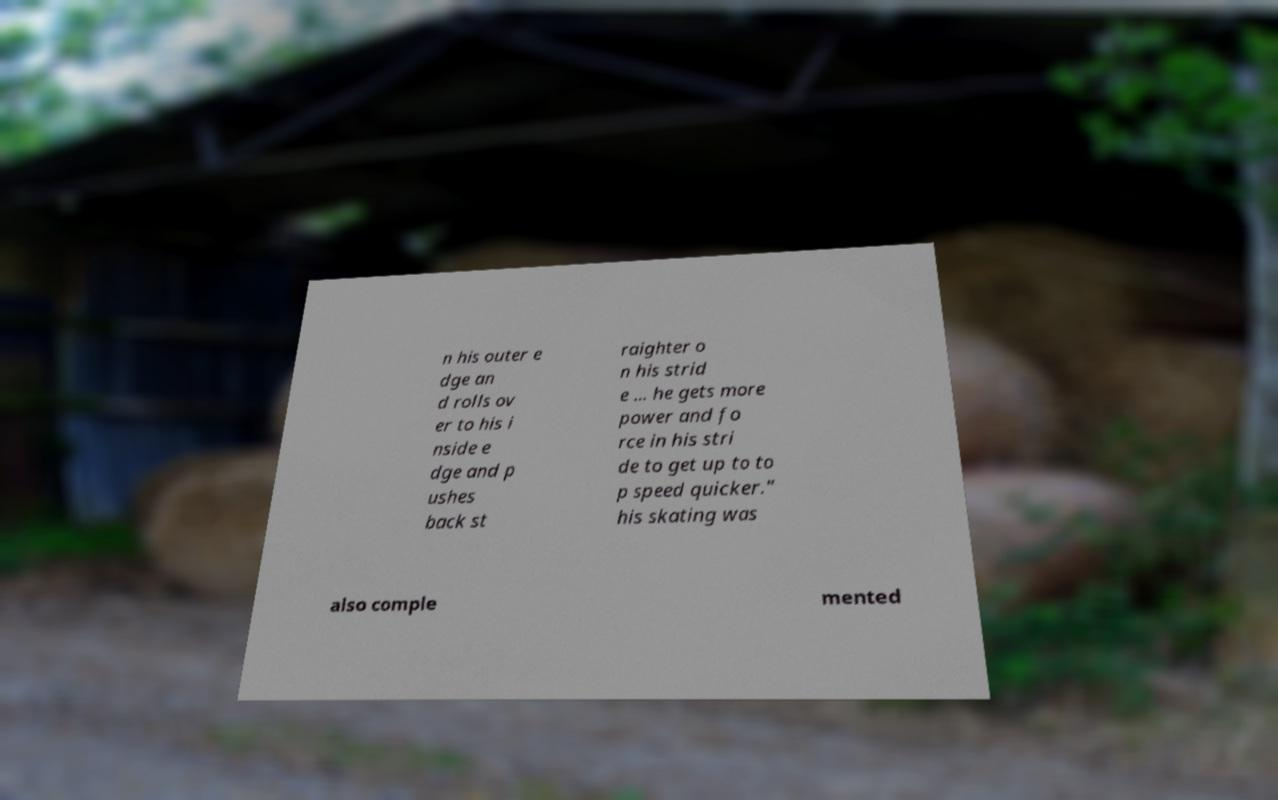Please read and relay the text visible in this image. What does it say? n his outer e dge an d rolls ov er to his i nside e dge and p ushes back st raighter o n his strid e ... he gets more power and fo rce in his stri de to get up to to p speed quicker." his skating was also comple mented 